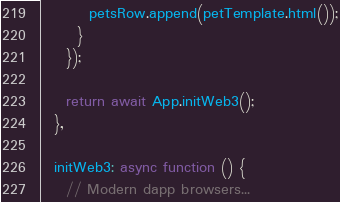<code> <loc_0><loc_0><loc_500><loc_500><_JavaScript_>
        petsRow.append(petTemplate.html());
      }
    });

    return await App.initWeb3();
  },

  initWeb3: async function () {
    // Modern dapp browsers...</code> 